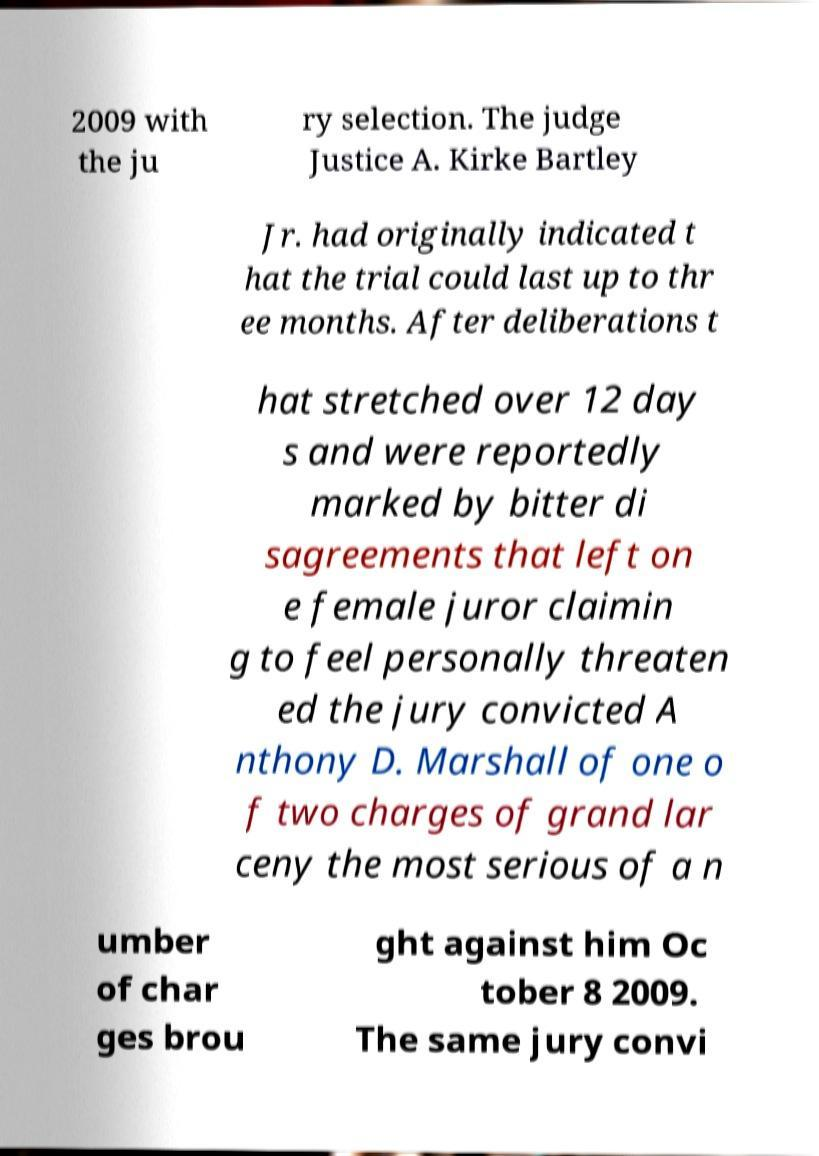There's text embedded in this image that I need extracted. Can you transcribe it verbatim? 2009 with the ju ry selection. The judge Justice A. Kirke Bartley Jr. had originally indicated t hat the trial could last up to thr ee months. After deliberations t hat stretched over 12 day s and were reportedly marked by bitter di sagreements that left on e female juror claimin g to feel personally threaten ed the jury convicted A nthony D. Marshall of one o f two charges of grand lar ceny the most serious of a n umber of char ges brou ght against him Oc tober 8 2009. The same jury convi 